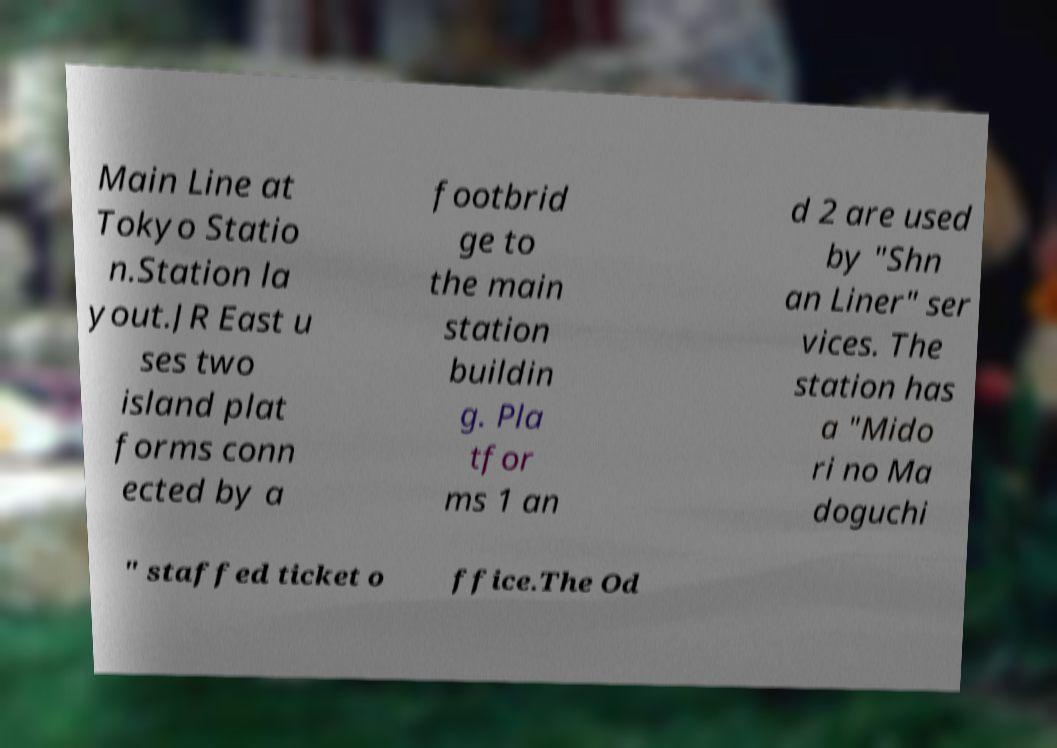For documentation purposes, I need the text within this image transcribed. Could you provide that? Main Line at Tokyo Statio n.Station la yout.JR East u ses two island plat forms conn ected by a footbrid ge to the main station buildin g. Pla tfor ms 1 an d 2 are used by "Shn an Liner" ser vices. The station has a "Mido ri no Ma doguchi " staffed ticket o ffice.The Od 